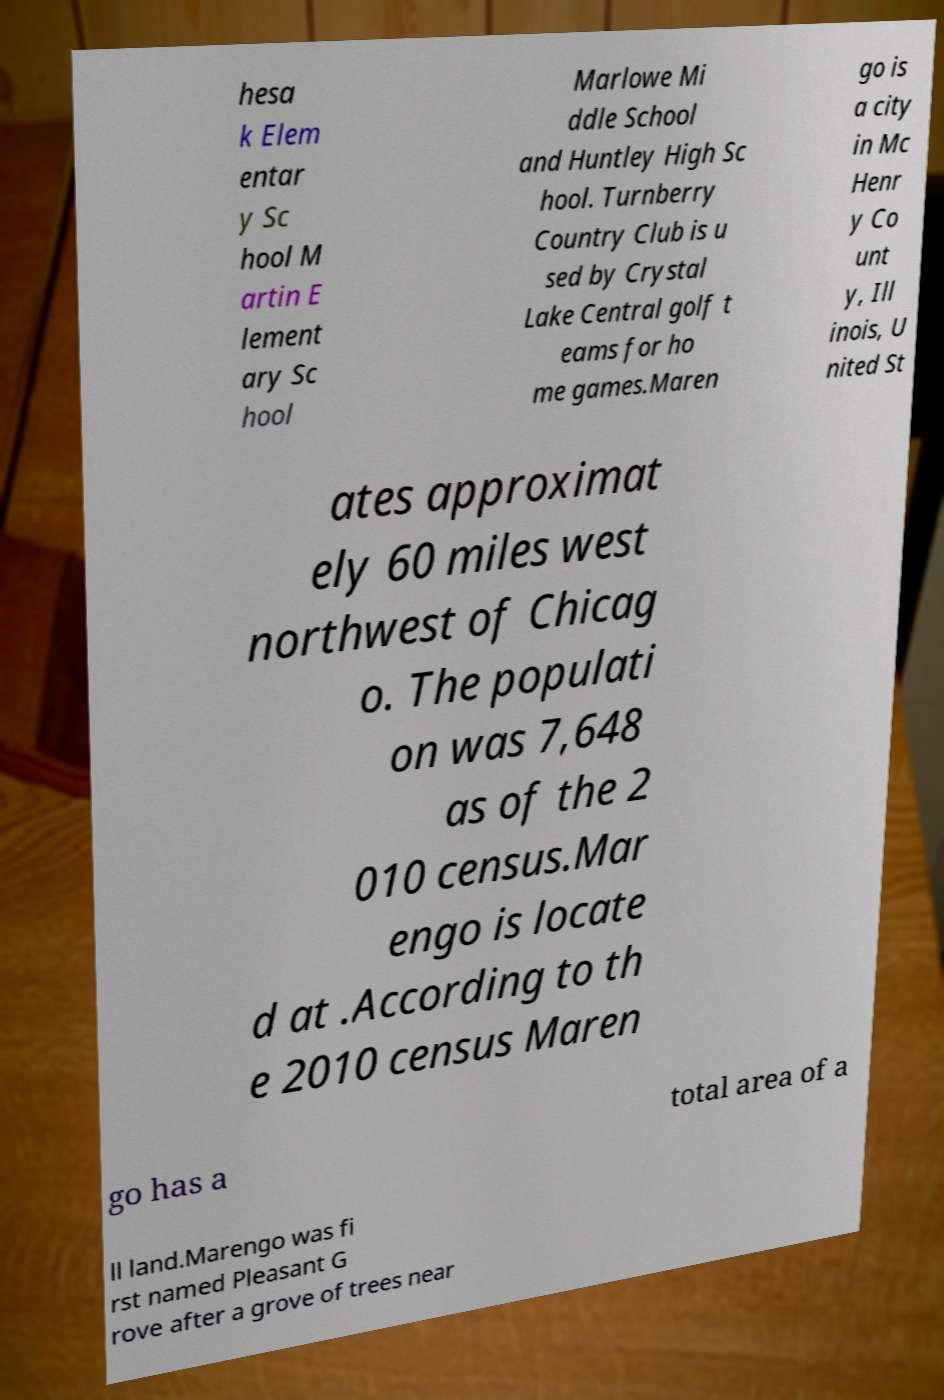Could you assist in decoding the text presented in this image and type it out clearly? hesa k Elem entar y Sc hool M artin E lement ary Sc hool Marlowe Mi ddle School and Huntley High Sc hool. Turnberry Country Club is u sed by Crystal Lake Central golf t eams for ho me games.Maren go is a city in Mc Henr y Co unt y, Ill inois, U nited St ates approximat ely 60 miles west northwest of Chicag o. The populati on was 7,648 as of the 2 010 census.Mar engo is locate d at .According to th e 2010 census Maren go has a total area of a ll land.Marengo was fi rst named Pleasant G rove after a grove of trees near 